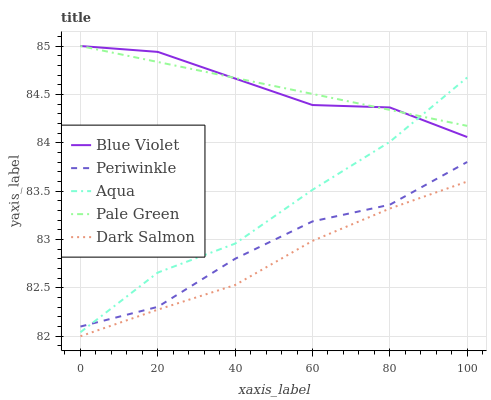Does Dark Salmon have the minimum area under the curve?
Answer yes or no. Yes. Does Pale Green have the maximum area under the curve?
Answer yes or no. Yes. Does Periwinkle have the minimum area under the curve?
Answer yes or no. No. Does Periwinkle have the maximum area under the curve?
Answer yes or no. No. Is Pale Green the smoothest?
Answer yes or no. Yes. Is Periwinkle the roughest?
Answer yes or no. Yes. Is Periwinkle the smoothest?
Answer yes or no. No. Is Pale Green the roughest?
Answer yes or no. No. Does Dark Salmon have the lowest value?
Answer yes or no. Yes. Does Periwinkle have the lowest value?
Answer yes or no. No. Does Blue Violet have the highest value?
Answer yes or no. Yes. Does Periwinkle have the highest value?
Answer yes or no. No. Is Dark Salmon less than Periwinkle?
Answer yes or no. Yes. Is Pale Green greater than Dark Salmon?
Answer yes or no. Yes. Does Aqua intersect Periwinkle?
Answer yes or no. Yes. Is Aqua less than Periwinkle?
Answer yes or no. No. Is Aqua greater than Periwinkle?
Answer yes or no. No. Does Dark Salmon intersect Periwinkle?
Answer yes or no. No. 